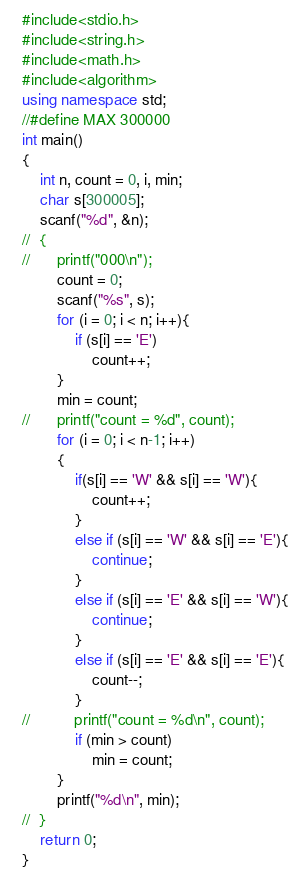<code> <loc_0><loc_0><loc_500><loc_500><_C++_>#include<stdio.h>
#include<string.h>
#include<math.h>
#include<algorithm>
using namespace std;
//#define MAX 300000
int main()
{
	int n, count = 0, i, min;
	char s[300005];
	scanf("%d", &n);
//	{
//		printf("000\n");
		count = 0;
		scanf("%s", s);
		for (i = 0; i < n; i++){
			if (s[i] == 'E')
				count++;
		}
		min = count;
//		printf("count = %d", count);
		for (i = 0; i < n-1; i++)
		{
			if(s[i] == 'W' && s[i] == 'W'){
				count++;
			}
			else if (s[i] == 'W' && s[i] == 'E'){
				continue;
			}
			else if (s[i] == 'E' && s[i] == 'W'){
				continue;
			}
			else if (s[i] == 'E' && s[i] == 'E'){
				count--;
			}
//			printf("count = %d\n", count);
			if (min > count)
				min = count;
		}
		printf("%d\n", min);
//	}
    return 0;
}
</code> 